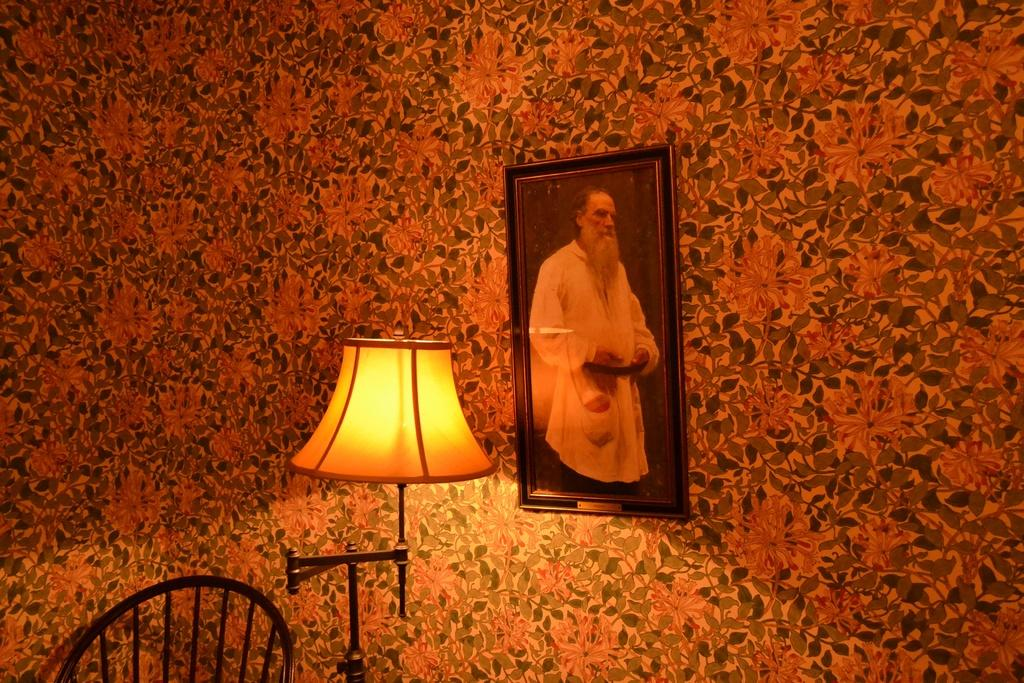What can be seen in the background of the image? There is a wall in the background of the image. What object in the image contains a picture or image? There is a photo frame in the image. What is depicted in the photo frame? A lamp is visible in the photo frame. What type of furniture is present in the image? There is a chair in the image. How many pigs are visible in the image? There are no pigs present in the image. What force is being applied to the wall in the image? There is no force being applied to the wall in the image; it is stationary. 